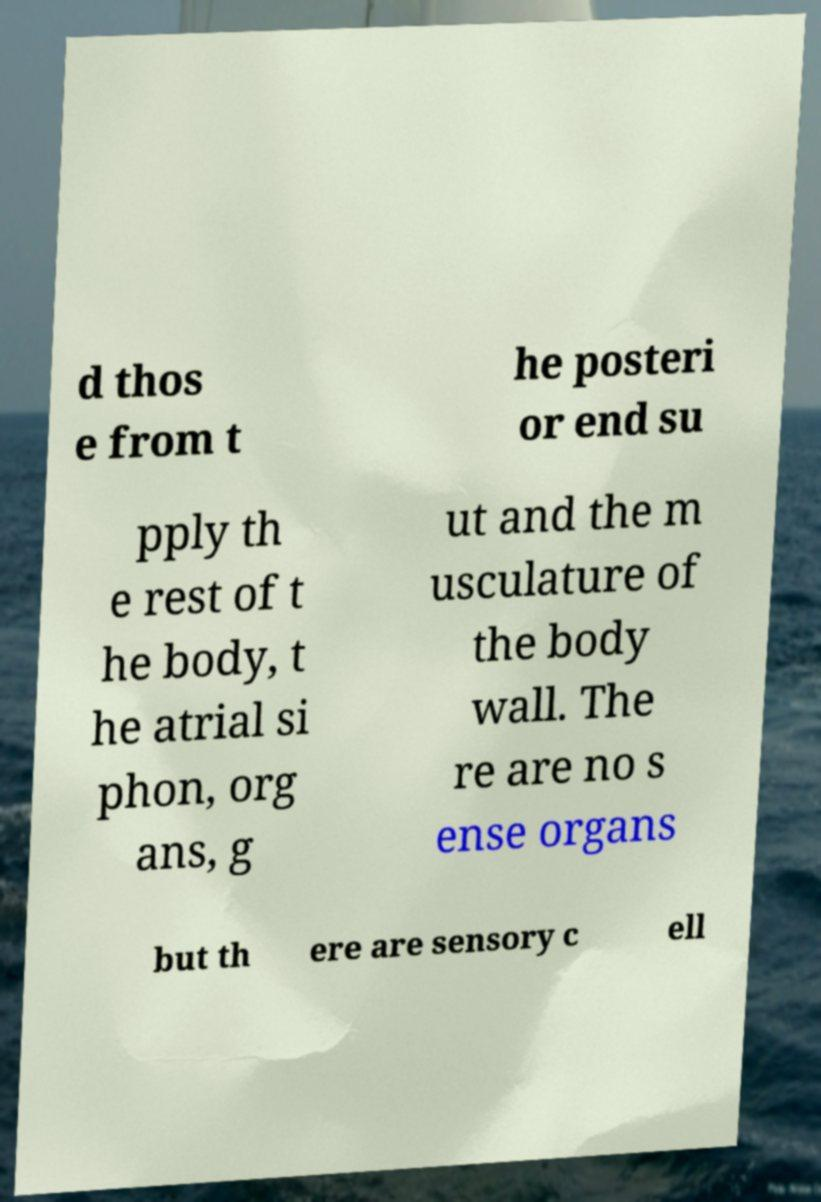Can you accurately transcribe the text from the provided image for me? d thos e from t he posteri or end su pply th e rest of t he body, t he atrial si phon, org ans, g ut and the m usculature of the body wall. The re are no s ense organs but th ere are sensory c ell 